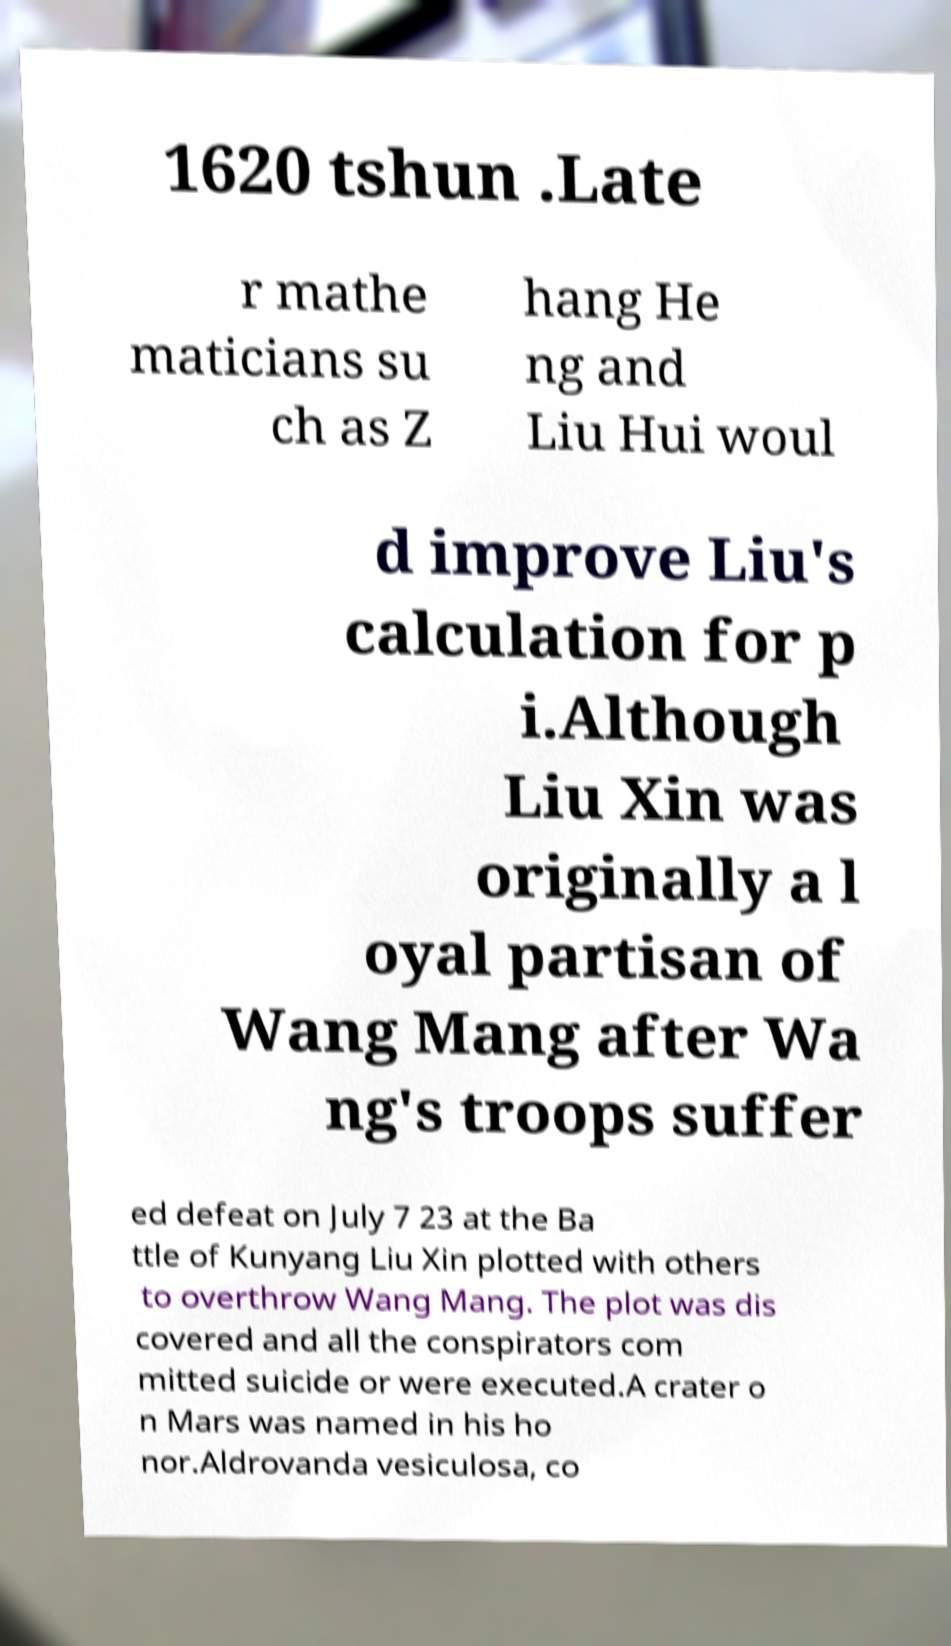Can you read and provide the text displayed in the image?This photo seems to have some interesting text. Can you extract and type it out for me? 1620 tshun .Late r mathe maticians su ch as Z hang He ng and Liu Hui woul d improve Liu's calculation for p i.Although Liu Xin was originally a l oyal partisan of Wang Mang after Wa ng's troops suffer ed defeat on July 7 23 at the Ba ttle of Kunyang Liu Xin plotted with others to overthrow Wang Mang. The plot was dis covered and all the conspirators com mitted suicide or were executed.A crater o n Mars was named in his ho nor.Aldrovanda vesiculosa, co 